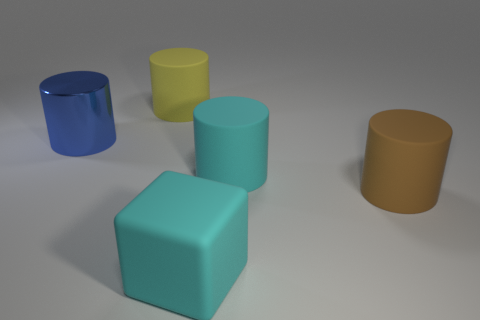Subtract all matte cylinders. How many cylinders are left? 1 Subtract all cyan cylinders. How many cylinders are left? 3 Subtract all green cubes. Subtract all blue spheres. How many cubes are left? 1 Subtract all cyan balls. How many blue blocks are left? 0 Subtract all rubber cubes. Subtract all cyan shiny blocks. How many objects are left? 4 Add 1 cubes. How many cubes are left? 2 Add 1 metallic cylinders. How many metallic cylinders exist? 2 Add 2 big blue things. How many objects exist? 7 Subtract 1 yellow cylinders. How many objects are left? 4 Subtract all cylinders. How many objects are left? 1 